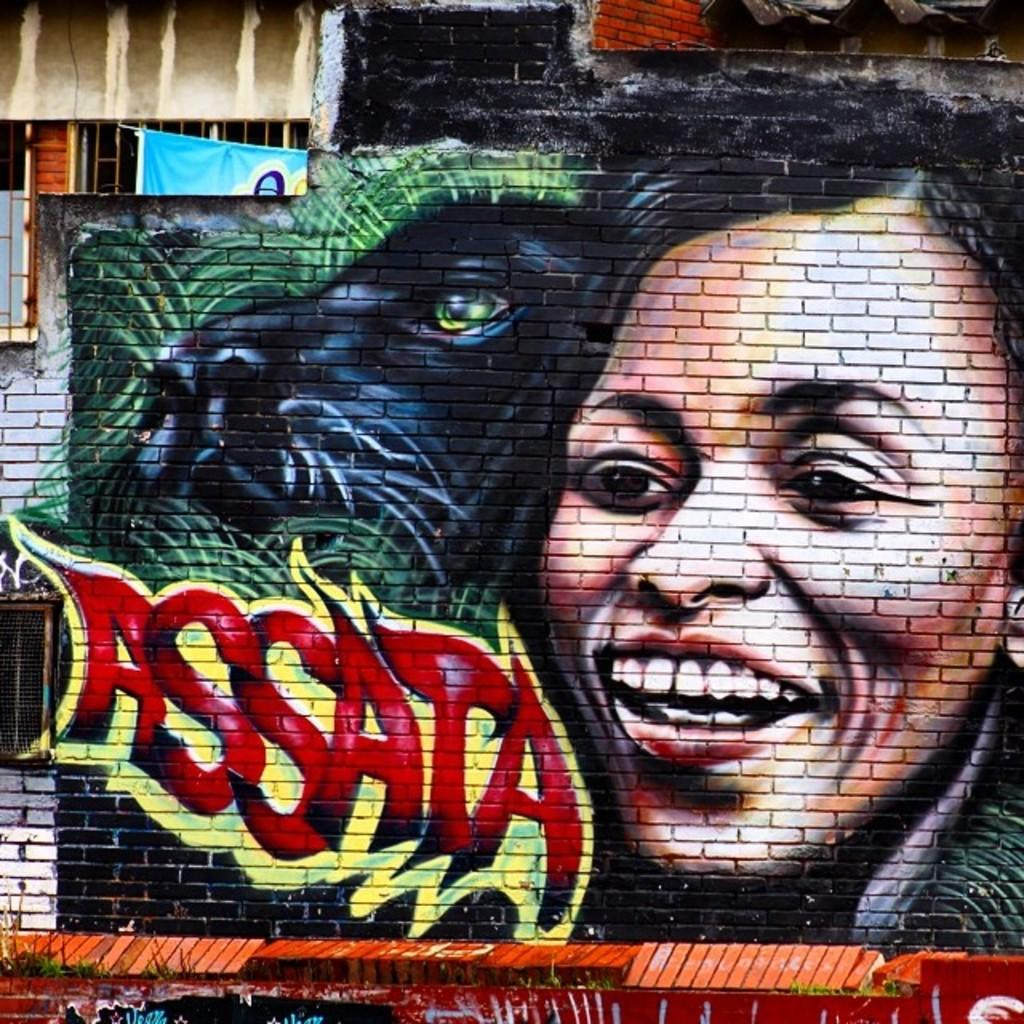What is depicted on the wall in the image? There is a graffiti painting on a wall in the image. Can you describe the graffiti painting? Unfortunately, the specific details of the graffiti painting cannot be determined from the provided fact. What is the background of the image? The background of the image is the wall on which the graffiti painting is located. What type of note is the crow holding in the image? There is no crow or note present in the image; it only features a graffiti painting on a wall. How does the jelly interact with the graffiti painting in the image? There is no jelly present in the image, so it cannot interact with the graffiti painting. 